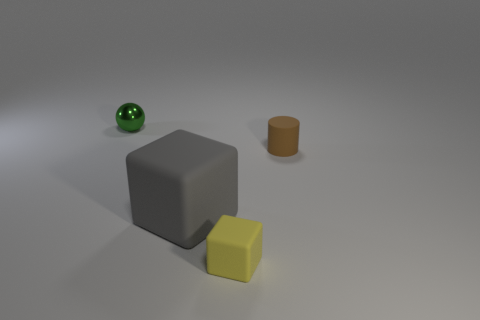Add 1 big cyan cylinders. How many objects exist? 5 Subtract all spheres. How many objects are left? 3 Subtract all yellow blocks. Subtract all small matte objects. How many objects are left? 1 Add 1 green things. How many green things are left? 2 Add 2 tiny rubber objects. How many tiny rubber objects exist? 4 Subtract 0 green blocks. How many objects are left? 4 